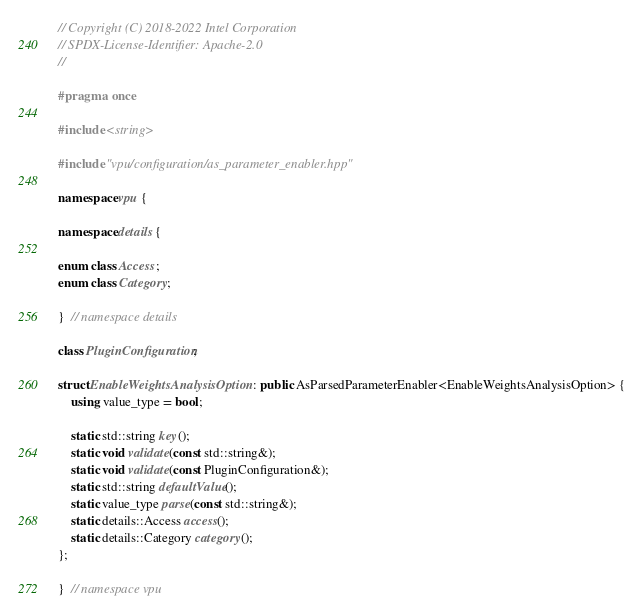Convert code to text. <code><loc_0><loc_0><loc_500><loc_500><_C++_>// Copyright (C) 2018-2022 Intel Corporation
// SPDX-License-Identifier: Apache-2.0
//

#pragma once

#include <string>

#include "vpu/configuration/as_parameter_enabler.hpp"

namespace vpu {

namespace details {

enum class Access;
enum class Category;

}  // namespace details

class PluginConfiguration;

struct EnableWeightsAnalysisOption : public AsParsedParameterEnabler<EnableWeightsAnalysisOption> {
    using value_type = bool;

    static std::string key();
    static void validate(const std::string&);
    static void validate(const PluginConfiguration&);
    static std::string defaultValue();
    static value_type parse(const std::string&);
    static details::Access access();
    static details::Category category();
};

}  // namespace vpu
</code> 